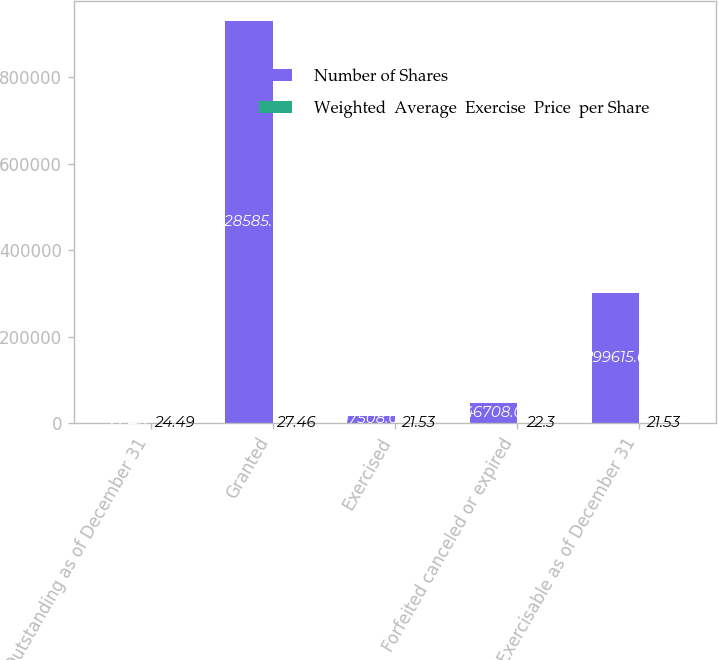Convert chart to OTSL. <chart><loc_0><loc_0><loc_500><loc_500><stacked_bar_chart><ecel><fcel>Outstanding as of December 31<fcel>Granted<fcel>Exercised<fcel>Forfeited canceled or expired<fcel>Exercisable as of December 31<nl><fcel>Number of Shares<fcel>27.46<fcel>928585<fcel>17508<fcel>46708<fcel>299615<nl><fcel>Weighted  Average  Exercise  Price  per Share<fcel>24.49<fcel>27.46<fcel>21.53<fcel>22.3<fcel>21.53<nl></chart> 